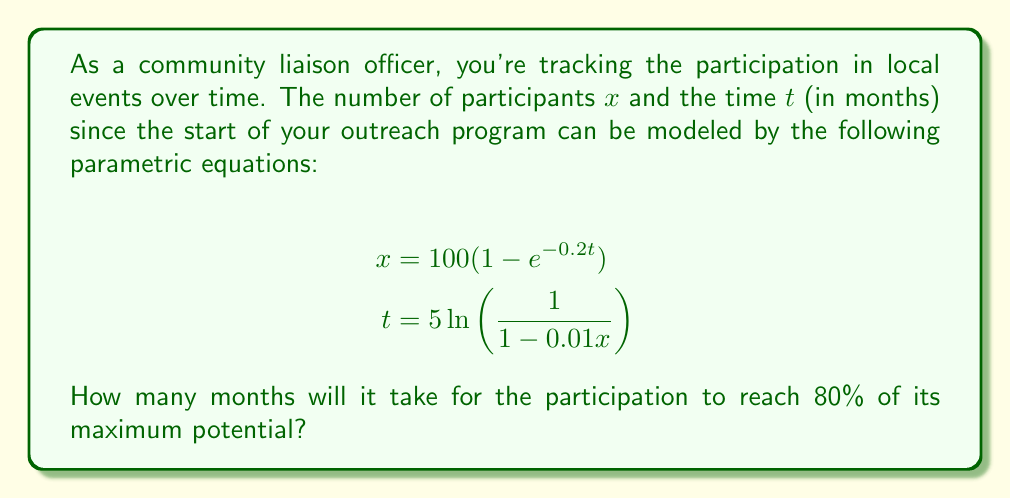Provide a solution to this math problem. To solve this problem, we need to follow these steps:

1) First, let's understand what the maximum potential participation is. From the equation for $x$, we can see that as $t$ approaches infinity, $e^{-0.2t}$ approaches 0, so the maximum value of $x$ is 100.

2) We want to find when participation reaches 80% of this maximum, which is:

   $80\% \text{ of } 100 = 0.8 \times 100 = 80$ participants

3) Now, we can use either of the given equations to solve for $t$ when $x = 80$. Let's use the second equation:

   $$t = 5\ln(\frac{1}{1-0.01x})$$

4) Substituting $x = 80$:

   $$t = 5\ln(\frac{1}{1-0.01(80)})$$

5) Simplify inside the parentheses:

   $$t = 5\ln(\frac{1}{1-0.8}) = 5\ln(\frac{1}{0.2})$$

6) Calculate:

   $$t = 5\ln(5) \approx 8.047$$

7) Since time is typically measured in whole months for community events, we should round up to the nearest month.
Answer: It will take 9 months for the participation to reach 80% of its maximum potential. 